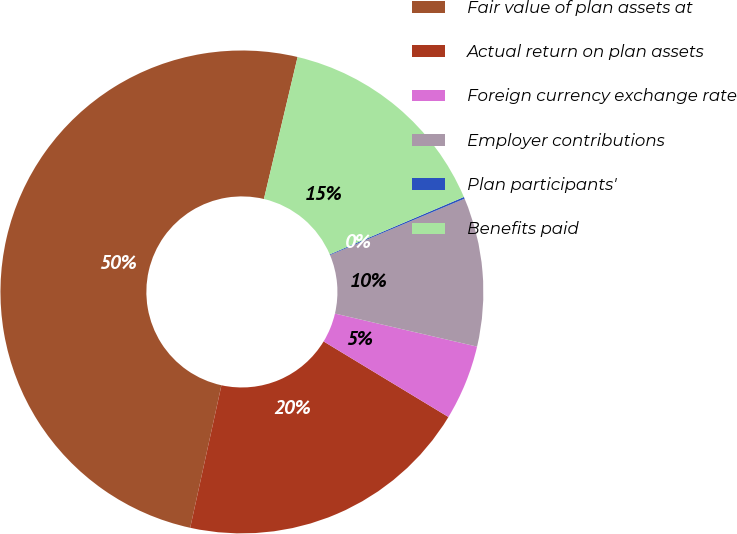Convert chart. <chart><loc_0><loc_0><loc_500><loc_500><pie_chart><fcel>Fair value of plan assets at<fcel>Actual return on plan assets<fcel>Foreign currency exchange rate<fcel>Employer contributions<fcel>Plan participants'<fcel>Benefits paid<nl><fcel>50.27%<fcel>19.77%<fcel>5.03%<fcel>9.95%<fcel>0.12%<fcel>14.86%<nl></chart> 